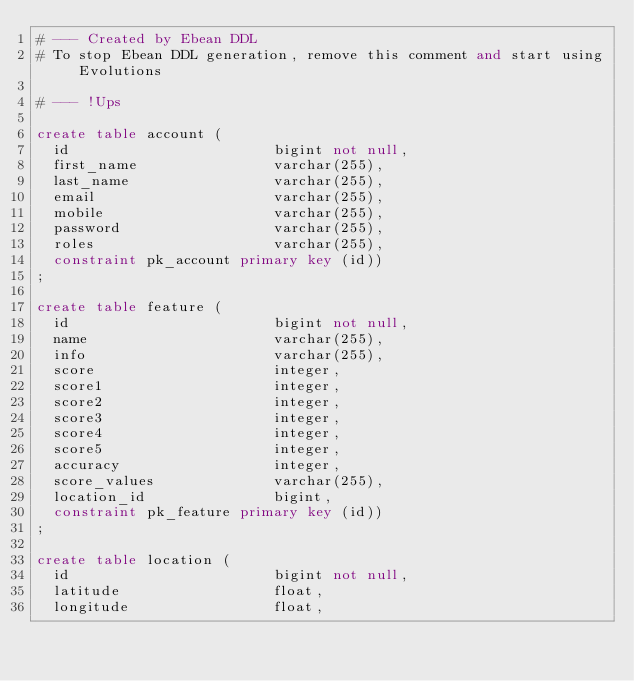Convert code to text. <code><loc_0><loc_0><loc_500><loc_500><_SQL_># --- Created by Ebean DDL
# To stop Ebean DDL generation, remove this comment and start using Evolutions

# --- !Ups

create table account (
  id                        bigint not null,
  first_name                varchar(255),
  last_name                 varchar(255),
  email                     varchar(255),
  mobile                    varchar(255),
  password                  varchar(255),
  roles                     varchar(255),
  constraint pk_account primary key (id))
;

create table feature (
  id                        bigint not null,
  name                      varchar(255),
  info                      varchar(255),
  score                     integer,
  score1                    integer,
  score2                    integer,
  score3                    integer,
  score4                    integer,
  score5                    integer,
  accuracy                  integer,
  score_values              varchar(255),
  location_id               bigint,
  constraint pk_feature primary key (id))
;

create table location (
  id                        bigint not null,
  latitude                  float,
  longitude                 float,</code> 